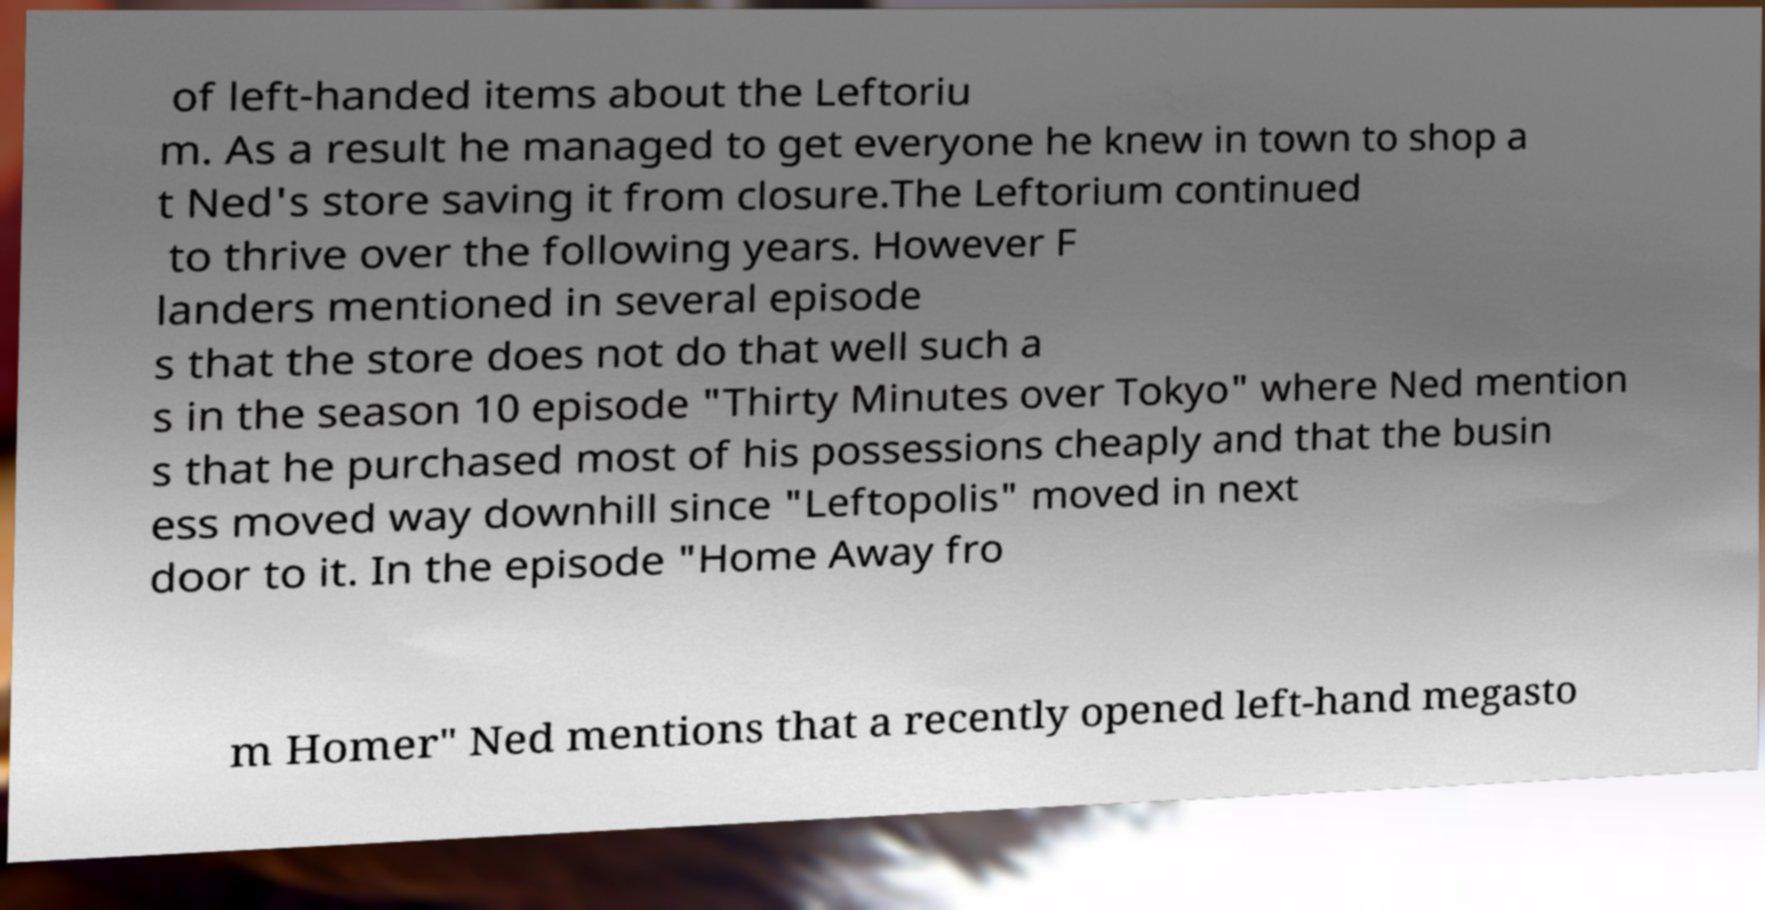Could you assist in decoding the text presented in this image and type it out clearly? of left-handed items about the Leftoriu m. As a result he managed to get everyone he knew in town to shop a t Ned's store saving it from closure.The Leftorium continued to thrive over the following years. However F landers mentioned in several episode s that the store does not do that well such a s in the season 10 episode "Thirty Minutes over Tokyo" where Ned mention s that he purchased most of his possessions cheaply and that the busin ess moved way downhill since "Leftopolis" moved in next door to it. In the episode "Home Away fro m Homer" Ned mentions that a recently opened left-hand megasto 